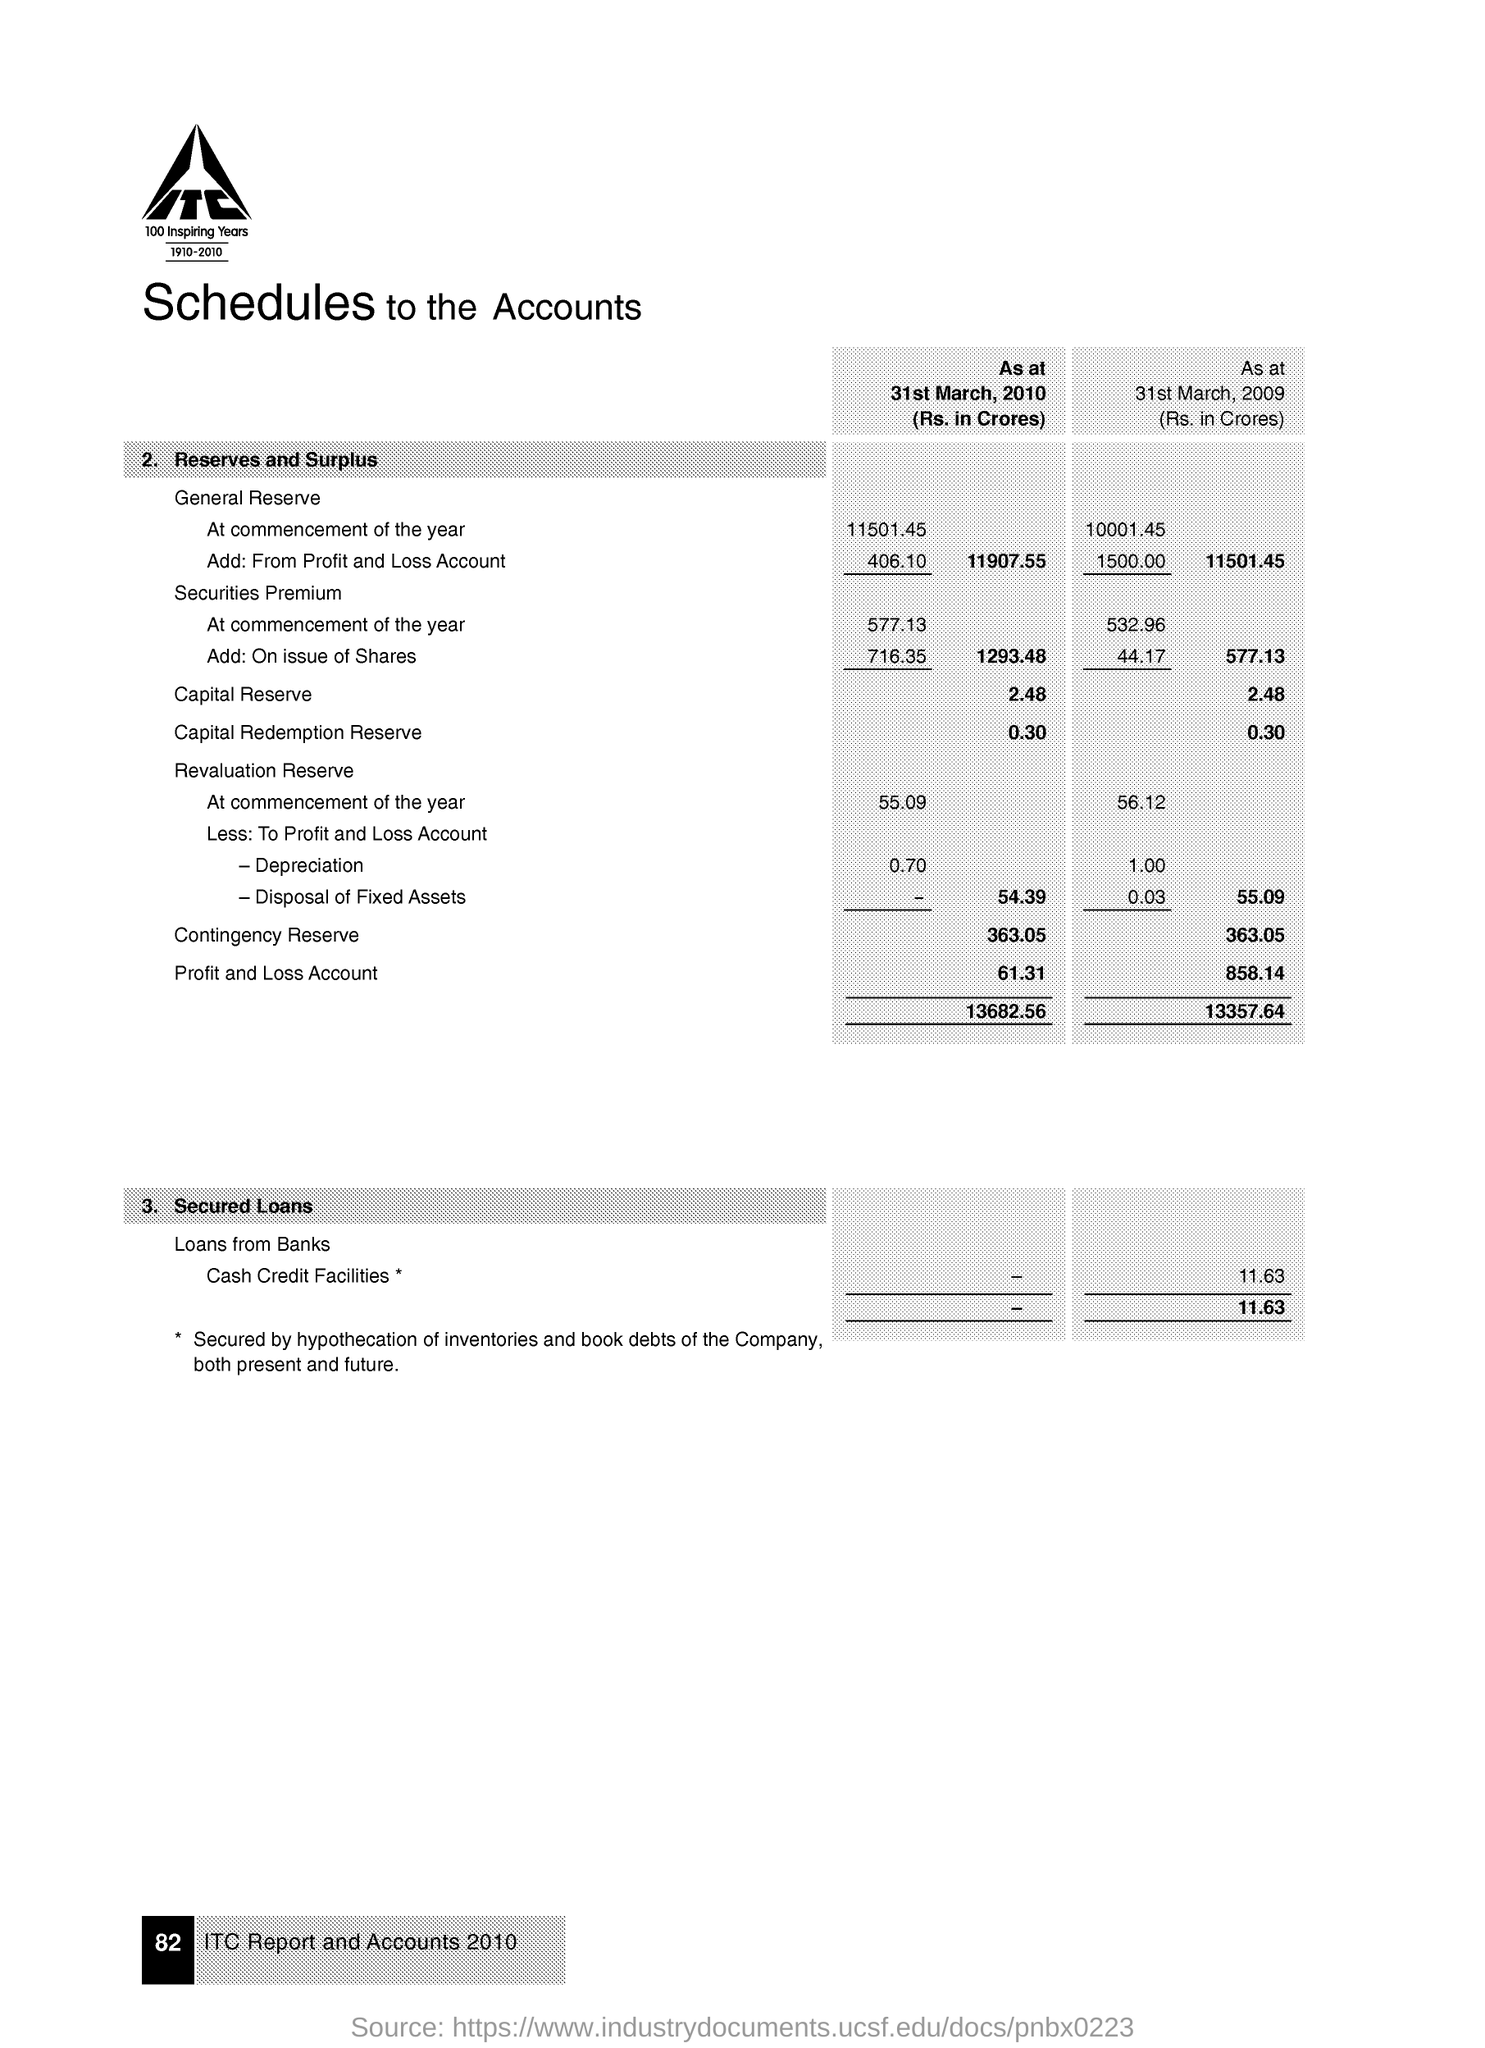Point out several critical features in this image. As of March 31, 2009, the contingency reserve was 363.05 crores. As of March 31, 2010, the capital reserve was Rs. 2,480 million. 